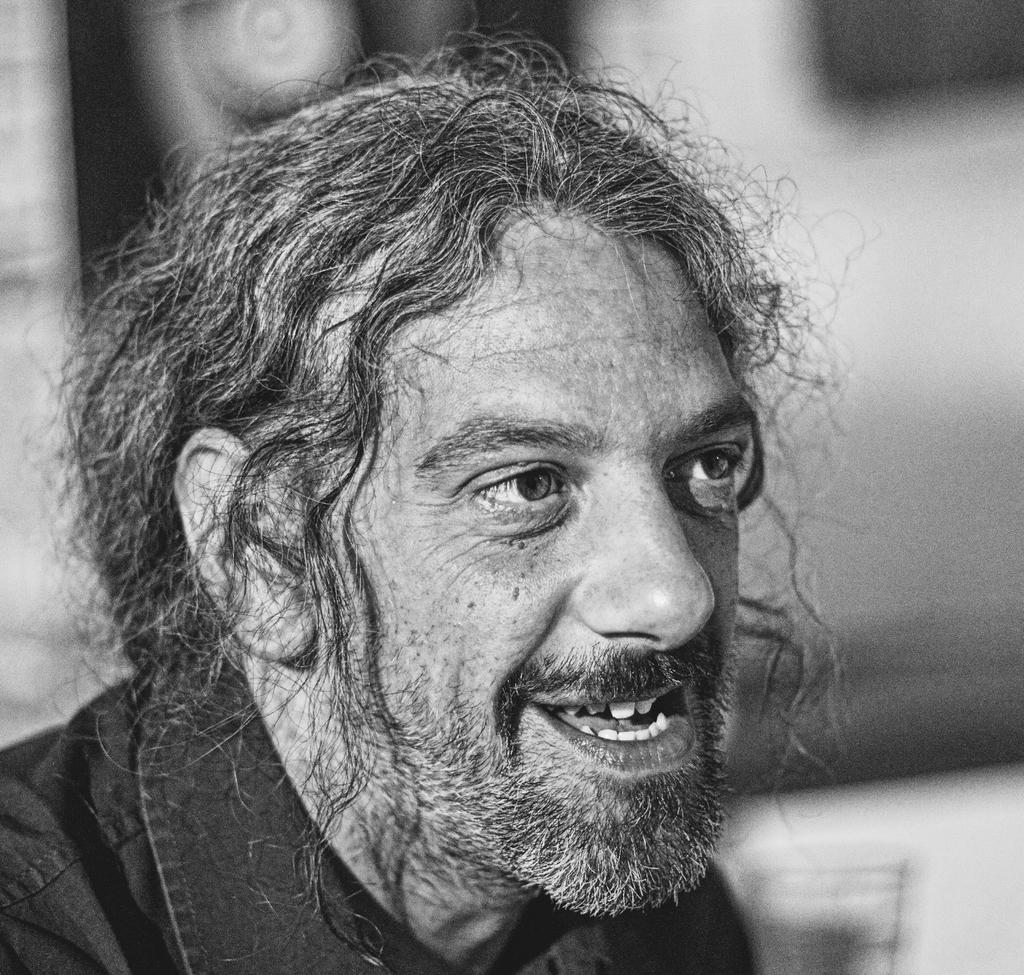What is the main subject of the image? There is a man in the image. What might the man be doing in the image? The man might be talking. Can you describe the background of the image? The background of the image is blurry. Can you see the ghost smiling in the image? There is no ghost present in the image, and therefore no smiling ghost can be observed. 